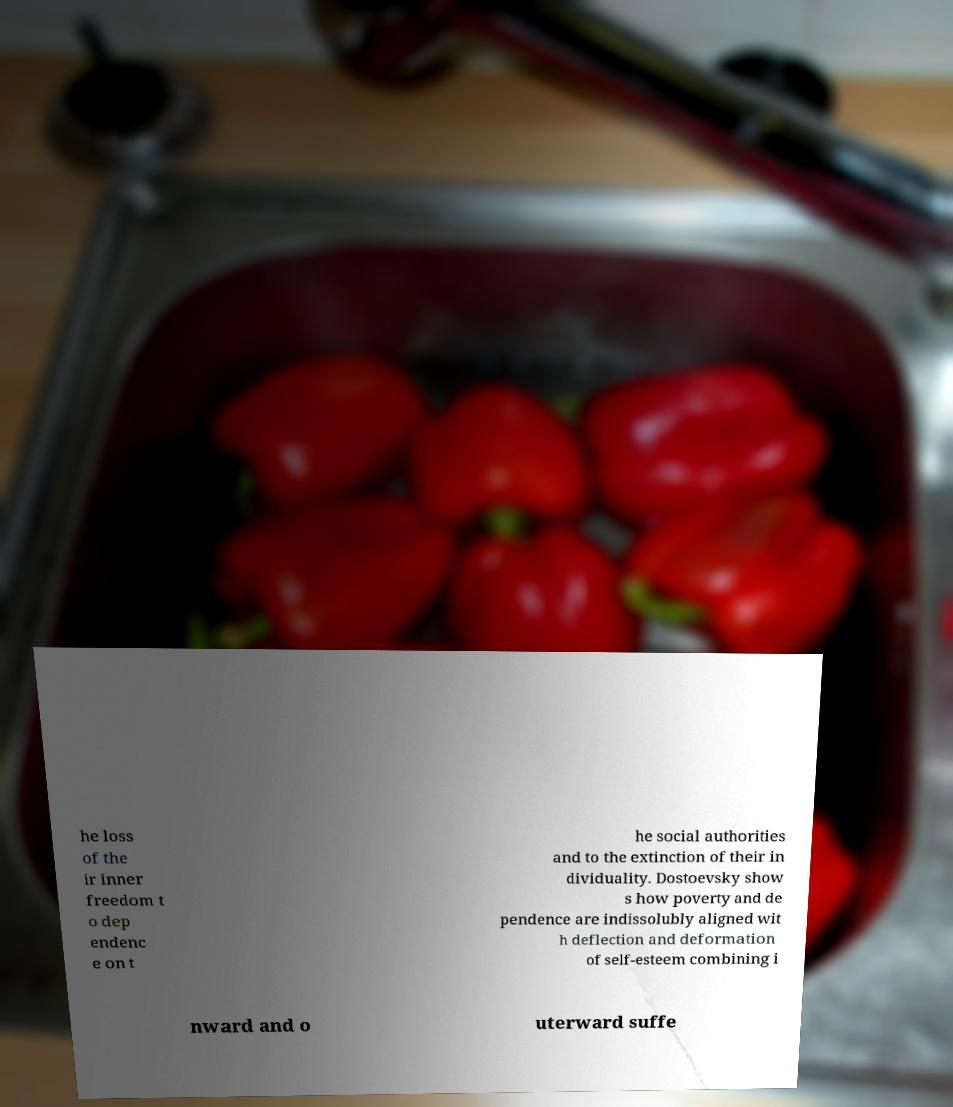Can you accurately transcribe the text from the provided image for me? he loss of the ir inner freedom t o dep endenc e on t he social authorities and to the extinction of their in dividuality. Dostoevsky show s how poverty and de pendence are indissolubly aligned wit h deflection and deformation of self-esteem combining i nward and o uterward suffe 